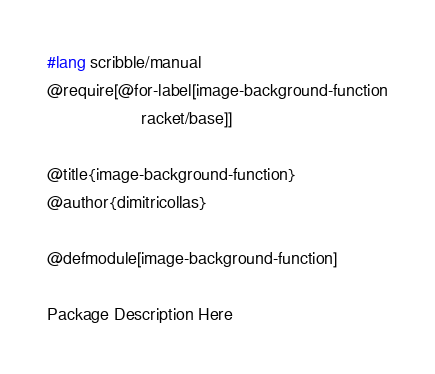Convert code to text. <code><loc_0><loc_0><loc_500><loc_500><_Racket_>#lang scribble/manual
@require[@for-label[image-background-function
                    racket/base]]

@title{image-background-function}
@author{dimitricollas}

@defmodule[image-background-function]

Package Description Here
</code> 